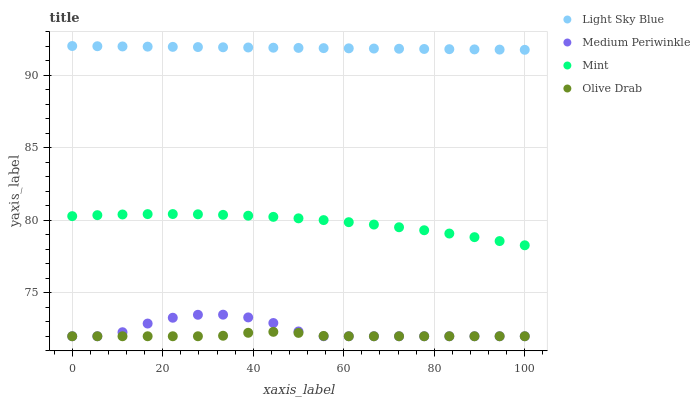Does Olive Drab have the minimum area under the curve?
Answer yes or no. Yes. Does Light Sky Blue have the maximum area under the curve?
Answer yes or no. Yes. Does Medium Periwinkle have the minimum area under the curve?
Answer yes or no. No. Does Medium Periwinkle have the maximum area under the curve?
Answer yes or no. No. Is Light Sky Blue the smoothest?
Answer yes or no. Yes. Is Medium Periwinkle the roughest?
Answer yes or no. Yes. Is Medium Periwinkle the smoothest?
Answer yes or no. No. Is Light Sky Blue the roughest?
Answer yes or no. No. Does Medium Periwinkle have the lowest value?
Answer yes or no. Yes. Does Light Sky Blue have the lowest value?
Answer yes or no. No. Does Light Sky Blue have the highest value?
Answer yes or no. Yes. Does Medium Periwinkle have the highest value?
Answer yes or no. No. Is Olive Drab less than Light Sky Blue?
Answer yes or no. Yes. Is Mint greater than Medium Periwinkle?
Answer yes or no. Yes. Does Olive Drab intersect Medium Periwinkle?
Answer yes or no. Yes. Is Olive Drab less than Medium Periwinkle?
Answer yes or no. No. Is Olive Drab greater than Medium Periwinkle?
Answer yes or no. No. Does Olive Drab intersect Light Sky Blue?
Answer yes or no. No. 